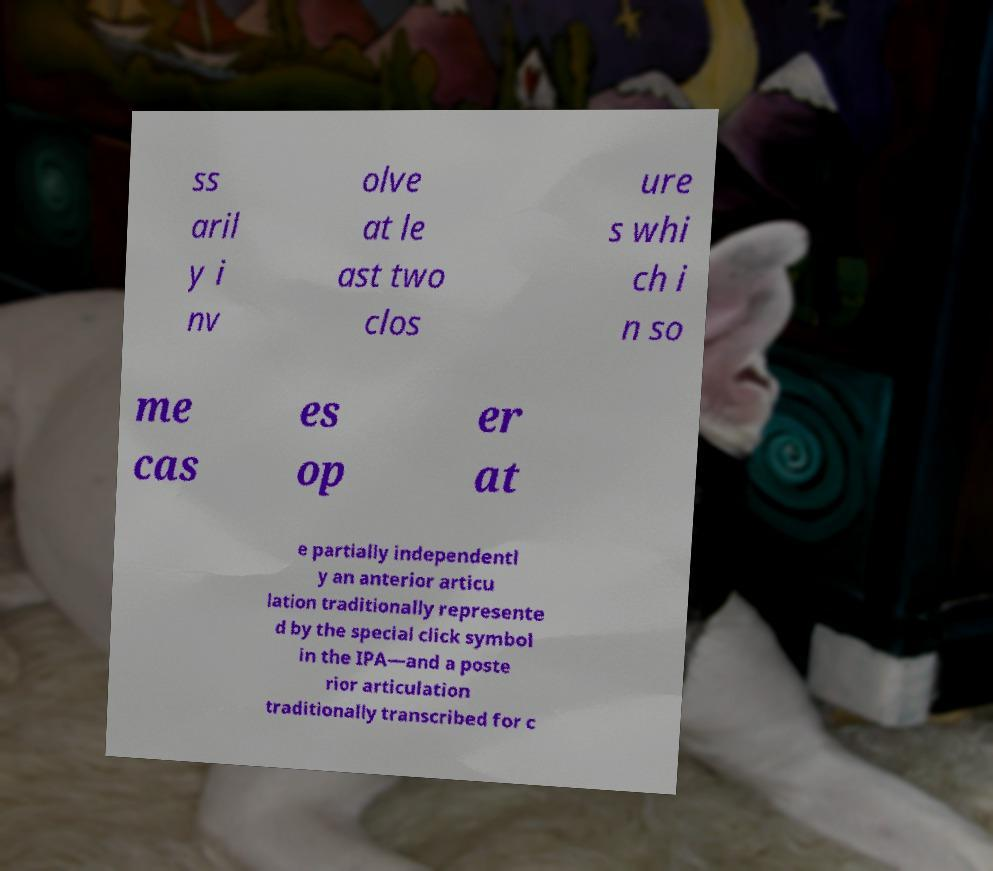There's text embedded in this image that I need extracted. Can you transcribe it verbatim? ss aril y i nv olve at le ast two clos ure s whi ch i n so me cas es op er at e partially independentl y an anterior articu lation traditionally represente d by the special click symbol in the IPA—and a poste rior articulation traditionally transcribed for c 